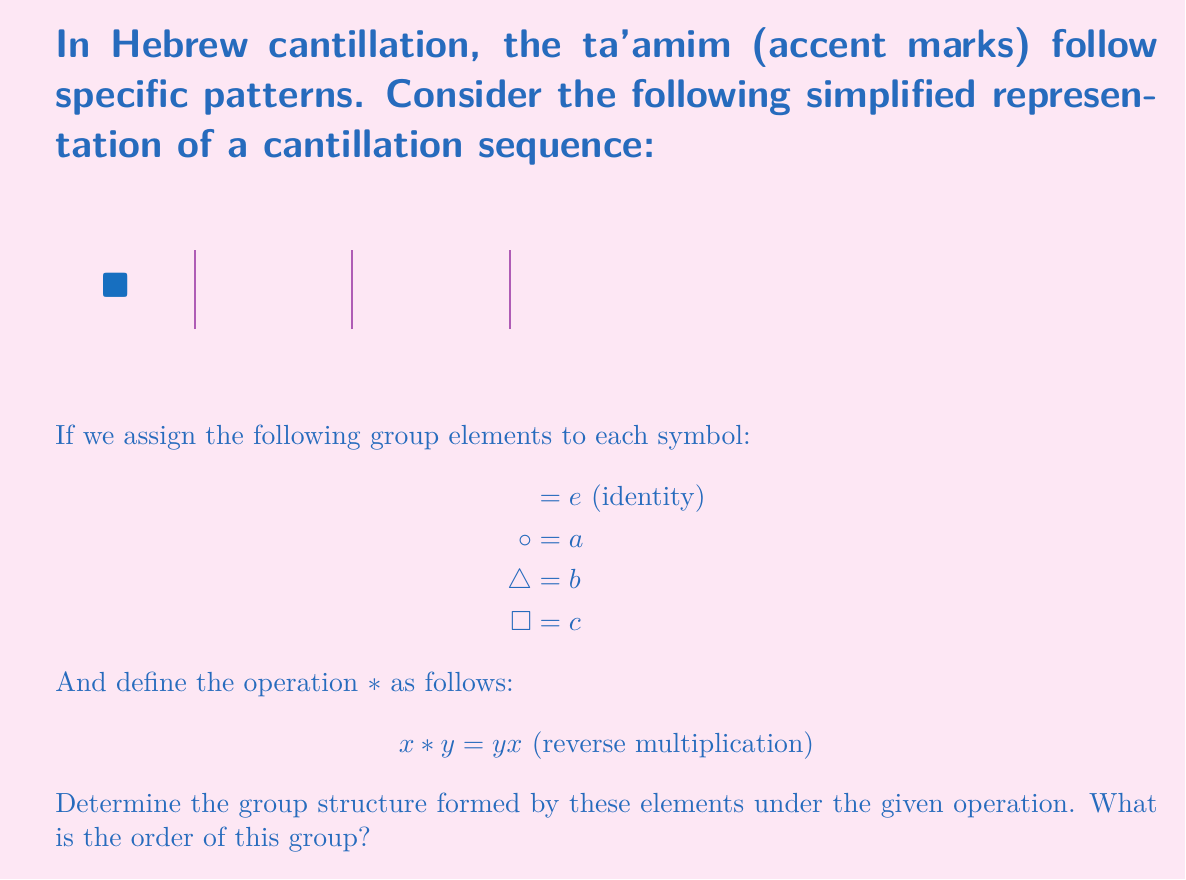Solve this math problem. Let's approach this step-by-step:

1) First, we need to verify if this forms a group under the given operation. For this, we need to check closure, associativity, identity, and inverses.

2) Closure: We need to ensure that all combinations of elements result in an element within the set. Let's create a multiplication table:

   ∗ | e | a | b | c
   ------------------
   e | e | a | b | c
   a | a | e | c | b
   b | b | c | e | a
   c | c | b | a | e

   We can see that all results are within the set {e, a, b, c}.

3) Associativity: $(x ∗ y) ∗ z = x ∗ (y ∗ z)$ for all x, y, z in the set. This holds due to the nature of the operation (reverse multiplication).

4) Identity: We can see from the table that e acts as the identity element.

5) Inverses: Each element is its own inverse (e.g., $a ∗ a = e$).

6) Since all group axioms are satisfied, this is indeed a group.

7) To determine the structure, we observe that:
   - Every element has order 2 (except the identity)
   - The group is non-abelian (e.g., $a ∗ b ≠ b ∗ a$)
   - It has 4 elements

8) This structure matches the dihedral group of order 4, often denoted as $D_4$ or $D_2$.

9) The order of the group is the number of elements, which is 4.
Answer: Dihedral group $D_4$ of order 4 